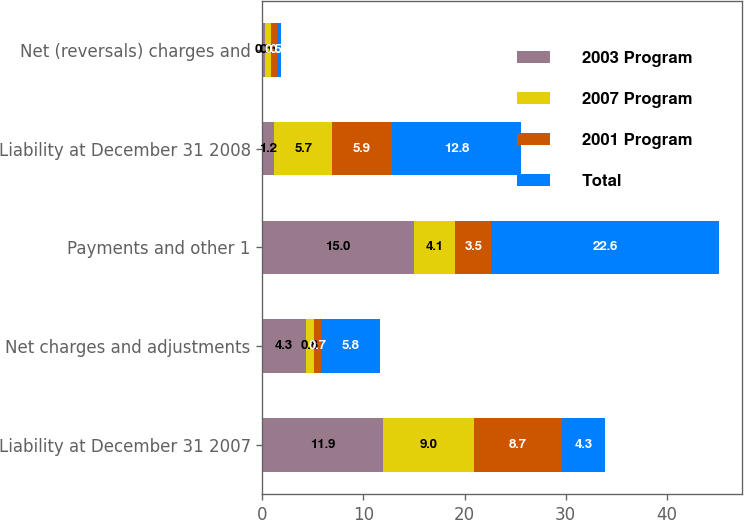Convert chart to OTSL. <chart><loc_0><loc_0><loc_500><loc_500><stacked_bar_chart><ecel><fcel>Liability at December 31 2007<fcel>Net charges and adjustments<fcel>Payments and other 1<fcel>Liability at December 31 2008<fcel>Net (reversals) charges and<nl><fcel>2003 Program<fcel>11.9<fcel>4.3<fcel>15<fcel>1.2<fcel>0.3<nl><fcel>2007 Program<fcel>9<fcel>0.8<fcel>4.1<fcel>5.7<fcel>0.6<nl><fcel>2001 Program<fcel>8.7<fcel>0.7<fcel>3.5<fcel>5.9<fcel>0.5<nl><fcel>Total<fcel>4.3<fcel>5.8<fcel>22.6<fcel>12.8<fcel>0.4<nl></chart> 